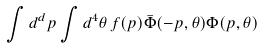<formula> <loc_0><loc_0><loc_500><loc_500>\int d ^ { d } p \int d ^ { 4 } \theta \, f ( p ) \bar { \Phi } ( - p , \theta ) \Phi ( p , \theta )</formula> 